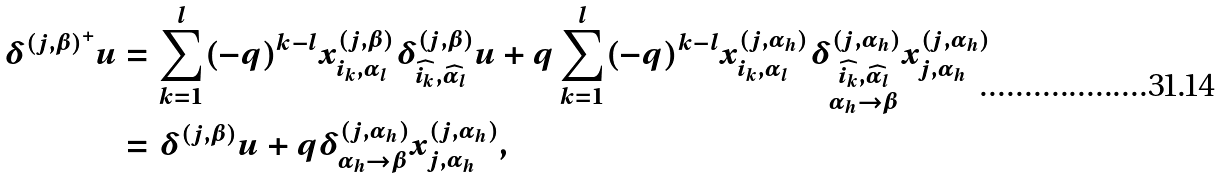Convert formula to latex. <formula><loc_0><loc_0><loc_500><loc_500>\delta ^ { ( j , \beta ) ^ { + } } u & = \sum _ { k = 1 } ^ { l } ( - q ) ^ { k - l } x _ { i _ { k } , \alpha _ { l } } ^ { ( j , \beta ) } \delta _ { \widehat { i _ { k } } , \widehat { \alpha _ { l } } } ^ { ( j , \beta ) } u + q \sum _ { k = 1 } ^ { l } ( - q ) ^ { k - l } x _ { i _ { k } , \alpha _ { l } } ^ { ( j , \alpha _ { h } ) } \delta ^ { ( j , \alpha _ { h } ) } _ { \substack { \widehat { i _ { k } } , \widehat { \alpha _ { l } } \\ \alpha _ { h } \rightarrow \beta } } x _ { j , \alpha _ { h } } ^ { ( j , \alpha _ { h } ) } \\ & = \delta ^ { ( j , \beta ) } u + q \delta _ { \alpha _ { h } \rightarrow \beta } ^ { ( j , \alpha _ { h } ) } x _ { j , \alpha _ { h } } ^ { ( j , \alpha _ { h } ) } ,</formula> 